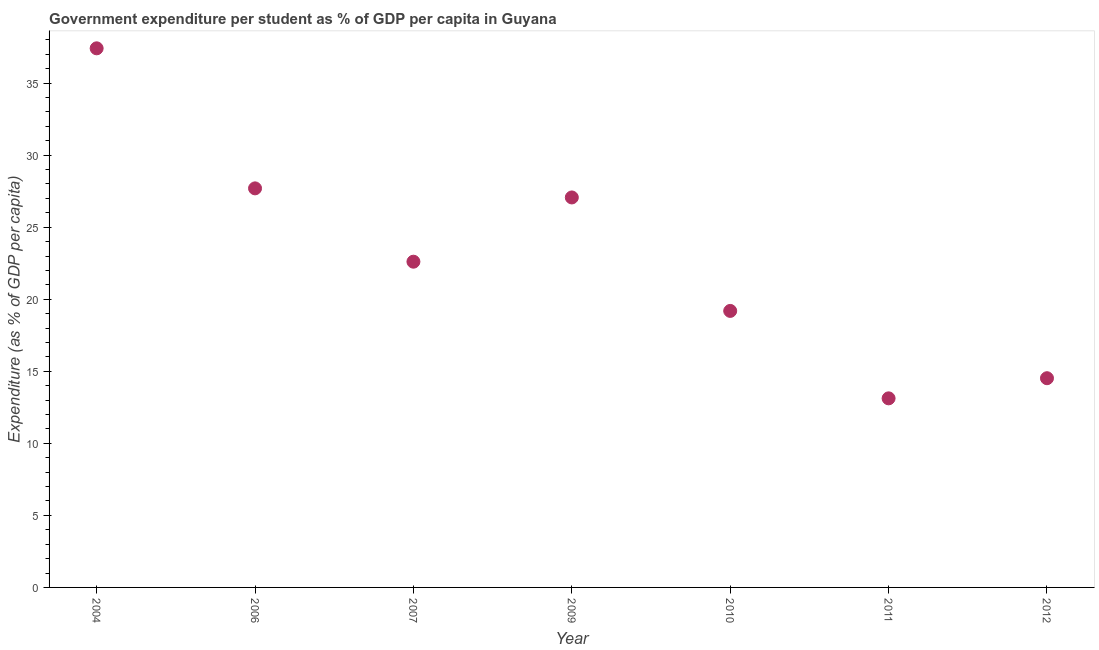What is the government expenditure per student in 2004?
Your answer should be compact. 37.41. Across all years, what is the maximum government expenditure per student?
Your answer should be very brief. 37.41. Across all years, what is the minimum government expenditure per student?
Provide a succinct answer. 13.12. In which year was the government expenditure per student minimum?
Give a very brief answer. 2011. What is the sum of the government expenditure per student?
Give a very brief answer. 161.61. What is the difference between the government expenditure per student in 2006 and 2007?
Make the answer very short. 5.09. What is the average government expenditure per student per year?
Provide a short and direct response. 23.09. What is the median government expenditure per student?
Your answer should be compact. 22.61. What is the ratio of the government expenditure per student in 2004 to that in 2007?
Provide a short and direct response. 1.66. Is the difference between the government expenditure per student in 2004 and 2012 greater than the difference between any two years?
Offer a terse response. No. What is the difference between the highest and the second highest government expenditure per student?
Your answer should be very brief. 9.72. Is the sum of the government expenditure per student in 2007 and 2009 greater than the maximum government expenditure per student across all years?
Make the answer very short. Yes. What is the difference between the highest and the lowest government expenditure per student?
Offer a terse response. 24.29. How many dotlines are there?
Offer a terse response. 1. What is the difference between two consecutive major ticks on the Y-axis?
Offer a very short reply. 5. Are the values on the major ticks of Y-axis written in scientific E-notation?
Provide a succinct answer. No. Does the graph contain any zero values?
Give a very brief answer. No. What is the title of the graph?
Offer a very short reply. Government expenditure per student as % of GDP per capita in Guyana. What is the label or title of the X-axis?
Offer a very short reply. Year. What is the label or title of the Y-axis?
Offer a terse response. Expenditure (as % of GDP per capita). What is the Expenditure (as % of GDP per capita) in 2004?
Make the answer very short. 37.41. What is the Expenditure (as % of GDP per capita) in 2006?
Keep it short and to the point. 27.7. What is the Expenditure (as % of GDP per capita) in 2007?
Offer a very short reply. 22.61. What is the Expenditure (as % of GDP per capita) in 2009?
Keep it short and to the point. 27.06. What is the Expenditure (as % of GDP per capita) in 2010?
Offer a very short reply. 19.19. What is the Expenditure (as % of GDP per capita) in 2011?
Provide a succinct answer. 13.12. What is the Expenditure (as % of GDP per capita) in 2012?
Make the answer very short. 14.52. What is the difference between the Expenditure (as % of GDP per capita) in 2004 and 2006?
Provide a succinct answer. 9.72. What is the difference between the Expenditure (as % of GDP per capita) in 2004 and 2007?
Make the answer very short. 14.81. What is the difference between the Expenditure (as % of GDP per capita) in 2004 and 2009?
Provide a short and direct response. 10.35. What is the difference between the Expenditure (as % of GDP per capita) in 2004 and 2010?
Your response must be concise. 18.22. What is the difference between the Expenditure (as % of GDP per capita) in 2004 and 2011?
Offer a terse response. 24.29. What is the difference between the Expenditure (as % of GDP per capita) in 2004 and 2012?
Your response must be concise. 22.89. What is the difference between the Expenditure (as % of GDP per capita) in 2006 and 2007?
Make the answer very short. 5.09. What is the difference between the Expenditure (as % of GDP per capita) in 2006 and 2009?
Provide a succinct answer. 0.63. What is the difference between the Expenditure (as % of GDP per capita) in 2006 and 2010?
Your answer should be compact. 8.5. What is the difference between the Expenditure (as % of GDP per capita) in 2006 and 2011?
Your answer should be compact. 14.57. What is the difference between the Expenditure (as % of GDP per capita) in 2006 and 2012?
Your response must be concise. 13.18. What is the difference between the Expenditure (as % of GDP per capita) in 2007 and 2009?
Your answer should be very brief. -4.46. What is the difference between the Expenditure (as % of GDP per capita) in 2007 and 2010?
Keep it short and to the point. 3.42. What is the difference between the Expenditure (as % of GDP per capita) in 2007 and 2011?
Provide a succinct answer. 9.48. What is the difference between the Expenditure (as % of GDP per capita) in 2007 and 2012?
Your response must be concise. 8.09. What is the difference between the Expenditure (as % of GDP per capita) in 2009 and 2010?
Your response must be concise. 7.87. What is the difference between the Expenditure (as % of GDP per capita) in 2009 and 2011?
Provide a short and direct response. 13.94. What is the difference between the Expenditure (as % of GDP per capita) in 2009 and 2012?
Keep it short and to the point. 12.55. What is the difference between the Expenditure (as % of GDP per capita) in 2010 and 2011?
Ensure brevity in your answer.  6.07. What is the difference between the Expenditure (as % of GDP per capita) in 2010 and 2012?
Make the answer very short. 4.67. What is the difference between the Expenditure (as % of GDP per capita) in 2011 and 2012?
Provide a succinct answer. -1.4. What is the ratio of the Expenditure (as % of GDP per capita) in 2004 to that in 2006?
Make the answer very short. 1.35. What is the ratio of the Expenditure (as % of GDP per capita) in 2004 to that in 2007?
Your response must be concise. 1.66. What is the ratio of the Expenditure (as % of GDP per capita) in 2004 to that in 2009?
Keep it short and to the point. 1.38. What is the ratio of the Expenditure (as % of GDP per capita) in 2004 to that in 2010?
Offer a very short reply. 1.95. What is the ratio of the Expenditure (as % of GDP per capita) in 2004 to that in 2011?
Your answer should be compact. 2.85. What is the ratio of the Expenditure (as % of GDP per capita) in 2004 to that in 2012?
Your response must be concise. 2.58. What is the ratio of the Expenditure (as % of GDP per capita) in 2006 to that in 2007?
Provide a short and direct response. 1.23. What is the ratio of the Expenditure (as % of GDP per capita) in 2006 to that in 2009?
Provide a succinct answer. 1.02. What is the ratio of the Expenditure (as % of GDP per capita) in 2006 to that in 2010?
Your answer should be compact. 1.44. What is the ratio of the Expenditure (as % of GDP per capita) in 2006 to that in 2011?
Your answer should be compact. 2.11. What is the ratio of the Expenditure (as % of GDP per capita) in 2006 to that in 2012?
Your answer should be very brief. 1.91. What is the ratio of the Expenditure (as % of GDP per capita) in 2007 to that in 2009?
Ensure brevity in your answer.  0.83. What is the ratio of the Expenditure (as % of GDP per capita) in 2007 to that in 2010?
Your answer should be very brief. 1.18. What is the ratio of the Expenditure (as % of GDP per capita) in 2007 to that in 2011?
Offer a terse response. 1.72. What is the ratio of the Expenditure (as % of GDP per capita) in 2007 to that in 2012?
Ensure brevity in your answer.  1.56. What is the ratio of the Expenditure (as % of GDP per capita) in 2009 to that in 2010?
Ensure brevity in your answer.  1.41. What is the ratio of the Expenditure (as % of GDP per capita) in 2009 to that in 2011?
Your answer should be compact. 2.06. What is the ratio of the Expenditure (as % of GDP per capita) in 2009 to that in 2012?
Give a very brief answer. 1.86. What is the ratio of the Expenditure (as % of GDP per capita) in 2010 to that in 2011?
Your answer should be very brief. 1.46. What is the ratio of the Expenditure (as % of GDP per capita) in 2010 to that in 2012?
Your answer should be very brief. 1.32. What is the ratio of the Expenditure (as % of GDP per capita) in 2011 to that in 2012?
Ensure brevity in your answer.  0.9. 